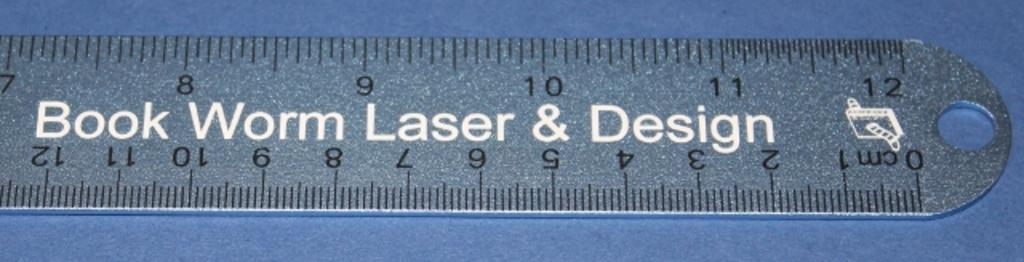<image>
Write a terse but informative summary of the picture. A ruler has Book Worm Laser and Design stamped on it. 